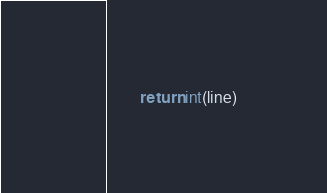<code> <loc_0><loc_0><loc_500><loc_500><_Python_>        return int(line)
</code> 